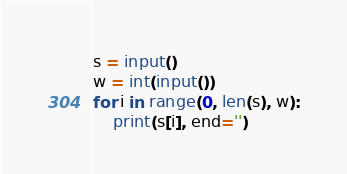Convert code to text. <code><loc_0><loc_0><loc_500><loc_500><_Python_>s = input()
w = int(input())
for i in range(0, len(s), w):
    print(s[i], end='')</code> 